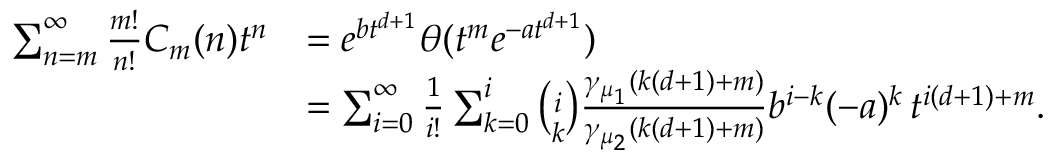<formula> <loc_0><loc_0><loc_500><loc_500>\begin{array} { r l } { \sum _ { n = m } ^ { \infty } { \frac { m ! } { n ! } } C _ { m } ( n ) t ^ { n } } & { = e ^ { b t ^ { d + 1 } } \theta ( t ^ { m } e ^ { - a t ^ { d + 1 } } ) } \\ & { = \sum _ { i = 0 } ^ { \infty } \frac { 1 } { i ! } \sum _ { k = 0 } ^ { i } { \binom { i } { k } } { \frac { \gamma _ { \mu _ { 1 } } ( k ( d + 1 ) + m ) } { \gamma _ { \mu _ { 2 } } ( k ( d + 1 ) + m ) } } b ^ { i - k } ( - a ) ^ { k } \, t ^ { i ( d + 1 ) + m } . } \end{array}</formula> 